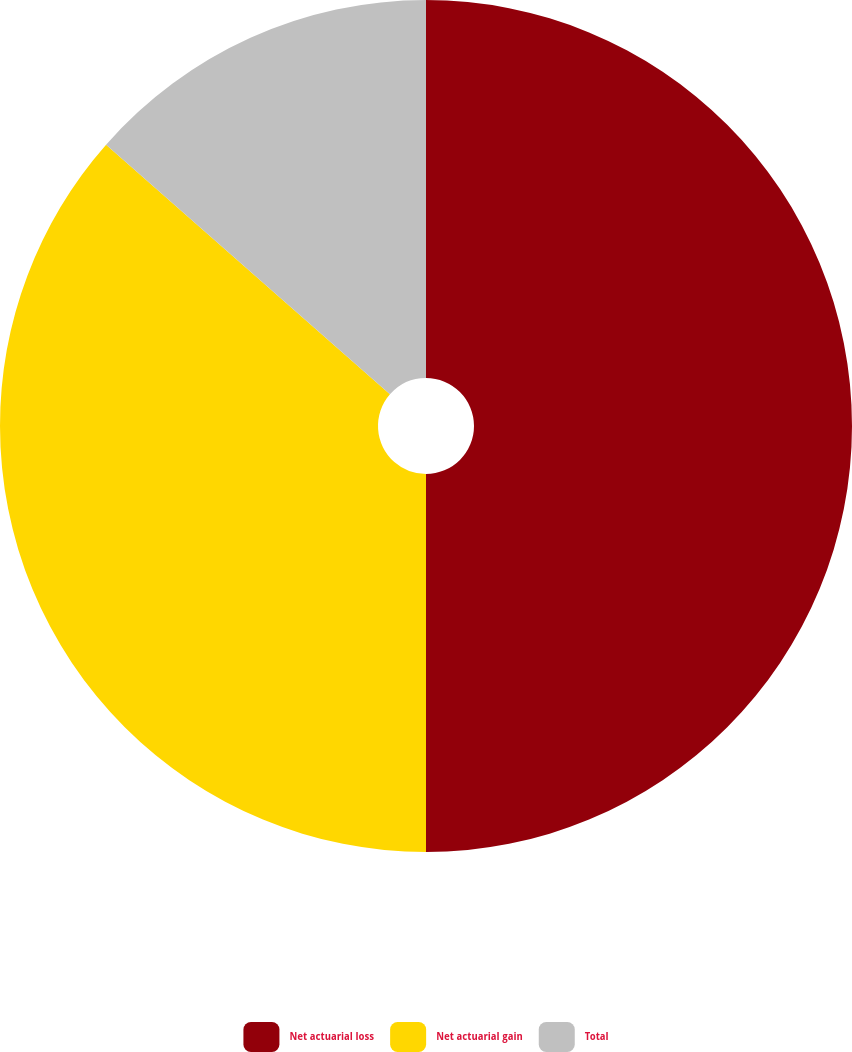Convert chart. <chart><loc_0><loc_0><loc_500><loc_500><pie_chart><fcel>Net actuarial loss<fcel>Net actuarial gain<fcel>Total<nl><fcel>50.0%<fcel>36.48%<fcel>13.52%<nl></chart> 